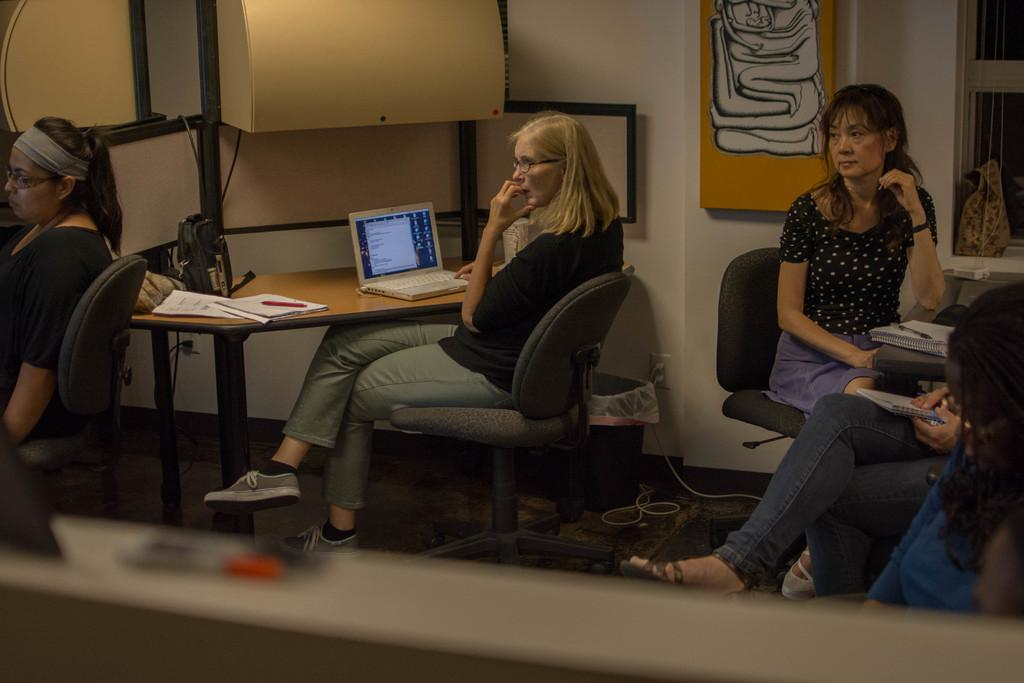How many women are in the image? There are 5 women in the image. What are the women doing in the image? The women are sitting. What can be seen on the tables in the image? There is a laptop and books on the table. What is visible in the background of the image? There is a wall and a window in the background of the image. What is the color of the coast visible through the window in the image? There is no coast visible through the window in the image; it only shows a wall and a window in the background. 